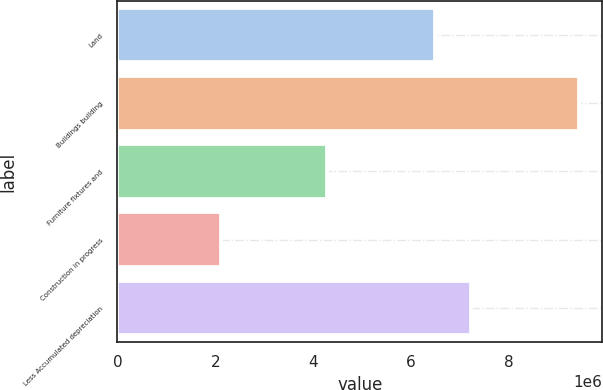Convert chart to OTSL. <chart><loc_0><loc_0><loc_500><loc_500><bar_chart><fcel>Land<fcel>Buildings building<fcel>Furniture fixtures and<fcel>Construction in progress<fcel>Less Accumulated depreciation<nl><fcel>6.49539e+06<fcel>9.42994e+06<fcel>4.27454e+06<fcel>2.11186e+06<fcel>7.2272e+06<nl></chart> 